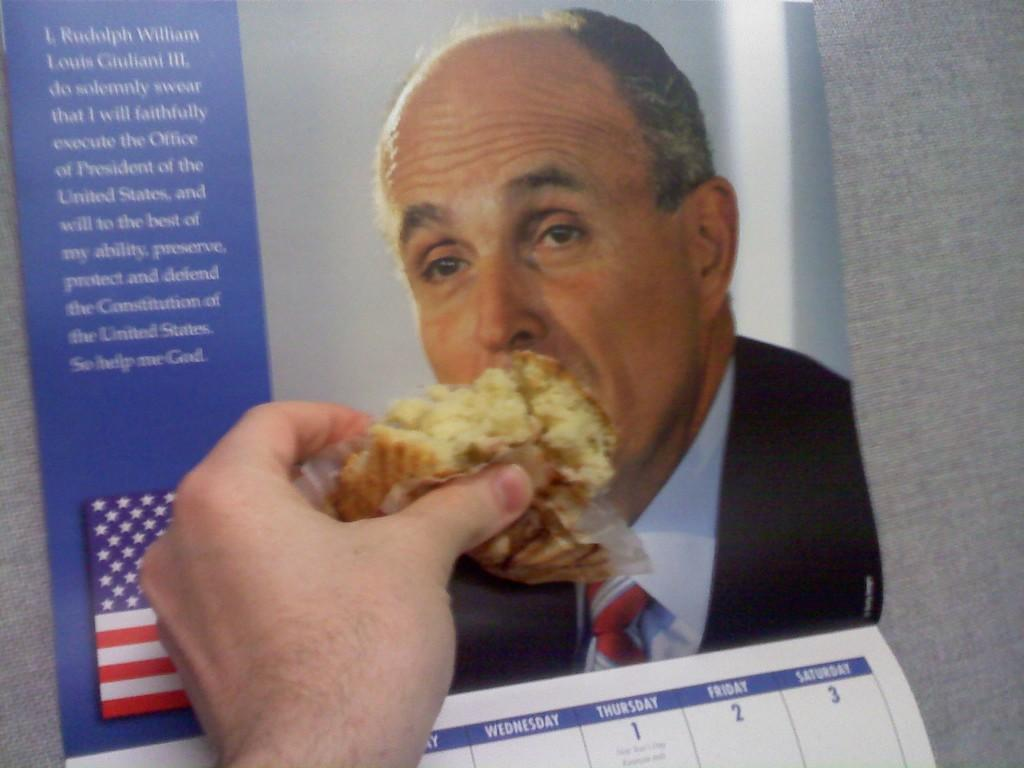<image>
Render a clear and concise summary of the photo. A calender with Rudolph Giuliani shows a hand feeding him a muffin 